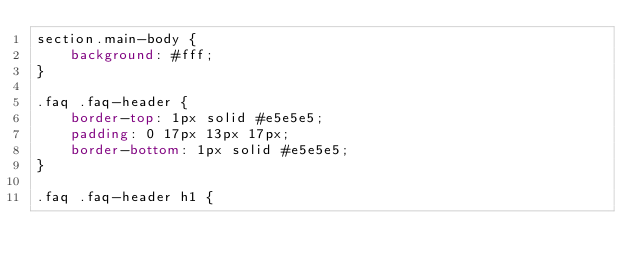Convert code to text. <code><loc_0><loc_0><loc_500><loc_500><_CSS_>section.main-body {
    background: #fff;
}

.faq .faq-header {
    border-top: 1px solid #e5e5e5;
    padding: 0 17px 13px 17px;
    border-bottom: 1px solid #e5e5e5;
}

.faq .faq-header h1 {</code> 